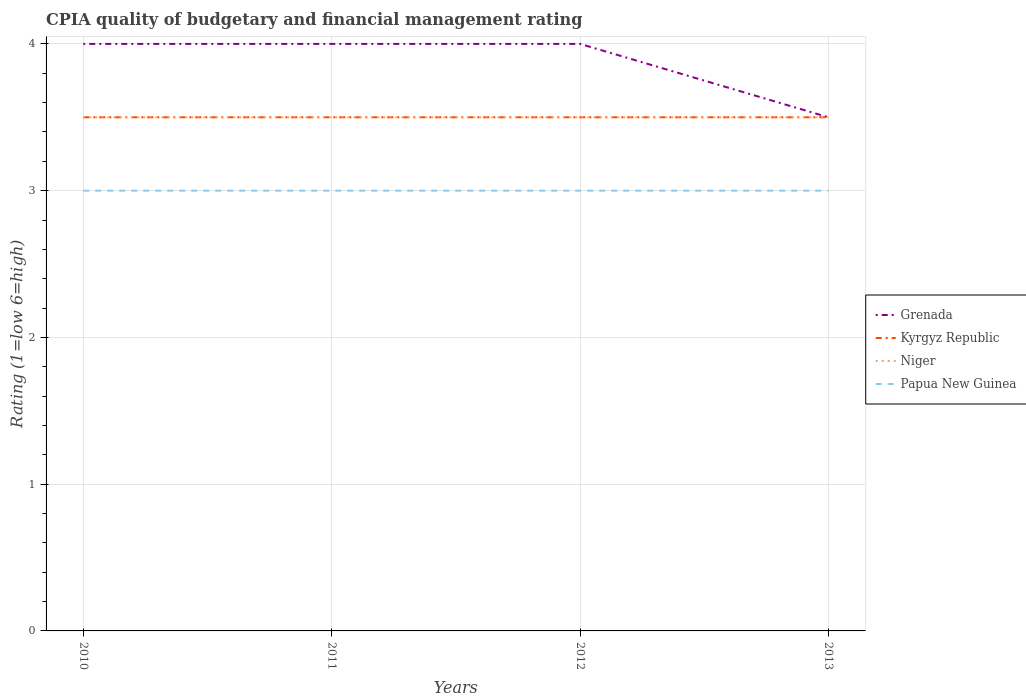How many different coloured lines are there?
Give a very brief answer. 4. Does the line corresponding to Papua New Guinea intersect with the line corresponding to Grenada?
Your answer should be compact. No. Is the number of lines equal to the number of legend labels?
Make the answer very short. Yes. What is the difference between the highest and the second highest CPIA rating in Niger?
Your answer should be compact. 0. What is the difference between the highest and the lowest CPIA rating in Papua New Guinea?
Offer a terse response. 0. Is the CPIA rating in Niger strictly greater than the CPIA rating in Grenada over the years?
Ensure brevity in your answer.  No. What is the difference between two consecutive major ticks on the Y-axis?
Your response must be concise. 1. Are the values on the major ticks of Y-axis written in scientific E-notation?
Your answer should be compact. No. Does the graph contain any zero values?
Your response must be concise. No. Where does the legend appear in the graph?
Provide a succinct answer. Center right. How are the legend labels stacked?
Ensure brevity in your answer.  Vertical. What is the title of the graph?
Offer a very short reply. CPIA quality of budgetary and financial management rating. Does "East Asia (developing only)" appear as one of the legend labels in the graph?
Your response must be concise. No. What is the label or title of the X-axis?
Provide a short and direct response. Years. What is the label or title of the Y-axis?
Provide a succinct answer. Rating (1=low 6=high). What is the Rating (1=low 6=high) in Kyrgyz Republic in 2010?
Offer a very short reply. 3.5. What is the Rating (1=low 6=high) of Niger in 2010?
Your answer should be very brief. 3.5. What is the Rating (1=low 6=high) of Grenada in 2011?
Keep it short and to the point. 4. What is the Rating (1=low 6=high) of Niger in 2011?
Provide a short and direct response. 3.5. What is the Rating (1=low 6=high) of Kyrgyz Republic in 2012?
Your answer should be very brief. 3.5. What is the Rating (1=low 6=high) in Niger in 2012?
Make the answer very short. 3.5. Across all years, what is the maximum Rating (1=low 6=high) in Grenada?
Offer a very short reply. 4. Across all years, what is the maximum Rating (1=low 6=high) of Kyrgyz Republic?
Keep it short and to the point. 3.5. Across all years, what is the maximum Rating (1=low 6=high) of Niger?
Offer a terse response. 3.5. Across all years, what is the minimum Rating (1=low 6=high) in Kyrgyz Republic?
Your response must be concise. 3.5. Across all years, what is the minimum Rating (1=low 6=high) of Niger?
Provide a succinct answer. 3.5. Across all years, what is the minimum Rating (1=low 6=high) of Papua New Guinea?
Make the answer very short. 3. What is the total Rating (1=low 6=high) of Grenada in the graph?
Your answer should be very brief. 15.5. What is the total Rating (1=low 6=high) of Kyrgyz Republic in the graph?
Offer a very short reply. 14. What is the total Rating (1=low 6=high) of Papua New Guinea in the graph?
Offer a very short reply. 12. What is the difference between the Rating (1=low 6=high) of Grenada in 2010 and that in 2011?
Make the answer very short. 0. What is the difference between the Rating (1=low 6=high) of Kyrgyz Republic in 2010 and that in 2011?
Your response must be concise. 0. What is the difference between the Rating (1=low 6=high) of Niger in 2010 and that in 2011?
Keep it short and to the point. 0. What is the difference between the Rating (1=low 6=high) of Papua New Guinea in 2010 and that in 2011?
Your answer should be very brief. 0. What is the difference between the Rating (1=low 6=high) of Niger in 2010 and that in 2012?
Your answer should be compact. 0. What is the difference between the Rating (1=low 6=high) of Papua New Guinea in 2010 and that in 2012?
Provide a short and direct response. 0. What is the difference between the Rating (1=low 6=high) in Kyrgyz Republic in 2010 and that in 2013?
Provide a short and direct response. 0. What is the difference between the Rating (1=low 6=high) in Papua New Guinea in 2011 and that in 2012?
Make the answer very short. 0. What is the difference between the Rating (1=low 6=high) of Grenada in 2011 and that in 2013?
Your answer should be compact. 0.5. What is the difference between the Rating (1=low 6=high) of Papua New Guinea in 2011 and that in 2013?
Keep it short and to the point. 0. What is the difference between the Rating (1=low 6=high) of Kyrgyz Republic in 2012 and that in 2013?
Offer a terse response. 0. What is the difference between the Rating (1=low 6=high) of Niger in 2012 and that in 2013?
Provide a short and direct response. 0. What is the difference between the Rating (1=low 6=high) of Papua New Guinea in 2012 and that in 2013?
Ensure brevity in your answer.  0. What is the difference between the Rating (1=low 6=high) in Grenada in 2010 and the Rating (1=low 6=high) in Niger in 2011?
Make the answer very short. 0.5. What is the difference between the Rating (1=low 6=high) in Grenada in 2010 and the Rating (1=low 6=high) in Papua New Guinea in 2011?
Ensure brevity in your answer.  1. What is the difference between the Rating (1=low 6=high) in Kyrgyz Republic in 2010 and the Rating (1=low 6=high) in Papua New Guinea in 2011?
Provide a short and direct response. 0.5. What is the difference between the Rating (1=low 6=high) of Niger in 2010 and the Rating (1=low 6=high) of Papua New Guinea in 2011?
Offer a very short reply. 0.5. What is the difference between the Rating (1=low 6=high) in Grenada in 2010 and the Rating (1=low 6=high) in Kyrgyz Republic in 2012?
Provide a succinct answer. 0.5. What is the difference between the Rating (1=low 6=high) of Grenada in 2010 and the Rating (1=low 6=high) of Papua New Guinea in 2012?
Provide a short and direct response. 1. What is the difference between the Rating (1=low 6=high) in Kyrgyz Republic in 2010 and the Rating (1=low 6=high) in Niger in 2012?
Ensure brevity in your answer.  0. What is the difference between the Rating (1=low 6=high) in Grenada in 2010 and the Rating (1=low 6=high) in Kyrgyz Republic in 2013?
Ensure brevity in your answer.  0.5. What is the difference between the Rating (1=low 6=high) in Grenada in 2010 and the Rating (1=low 6=high) in Papua New Guinea in 2013?
Your answer should be very brief. 1. What is the difference between the Rating (1=low 6=high) of Niger in 2010 and the Rating (1=low 6=high) of Papua New Guinea in 2013?
Offer a terse response. 0.5. What is the difference between the Rating (1=low 6=high) in Grenada in 2011 and the Rating (1=low 6=high) in Niger in 2012?
Your response must be concise. 0.5. What is the difference between the Rating (1=low 6=high) of Grenada in 2011 and the Rating (1=low 6=high) of Papua New Guinea in 2012?
Ensure brevity in your answer.  1. What is the difference between the Rating (1=low 6=high) in Kyrgyz Republic in 2011 and the Rating (1=low 6=high) in Niger in 2012?
Provide a short and direct response. 0. What is the difference between the Rating (1=low 6=high) in Kyrgyz Republic in 2011 and the Rating (1=low 6=high) in Papua New Guinea in 2012?
Provide a short and direct response. 0.5. What is the difference between the Rating (1=low 6=high) of Grenada in 2011 and the Rating (1=low 6=high) of Papua New Guinea in 2013?
Your answer should be very brief. 1. What is the difference between the Rating (1=low 6=high) of Kyrgyz Republic in 2011 and the Rating (1=low 6=high) of Niger in 2013?
Your response must be concise. 0. What is the difference between the Rating (1=low 6=high) of Niger in 2011 and the Rating (1=low 6=high) of Papua New Guinea in 2013?
Your answer should be very brief. 0.5. What is the difference between the Rating (1=low 6=high) in Kyrgyz Republic in 2012 and the Rating (1=low 6=high) in Niger in 2013?
Provide a succinct answer. 0. What is the difference between the Rating (1=low 6=high) of Kyrgyz Republic in 2012 and the Rating (1=low 6=high) of Papua New Guinea in 2013?
Give a very brief answer. 0.5. What is the average Rating (1=low 6=high) in Grenada per year?
Provide a succinct answer. 3.88. What is the average Rating (1=low 6=high) of Niger per year?
Keep it short and to the point. 3.5. In the year 2010, what is the difference between the Rating (1=low 6=high) in Grenada and Rating (1=low 6=high) in Niger?
Make the answer very short. 0.5. In the year 2010, what is the difference between the Rating (1=low 6=high) in Kyrgyz Republic and Rating (1=low 6=high) in Niger?
Provide a short and direct response. 0. In the year 2010, what is the difference between the Rating (1=low 6=high) in Niger and Rating (1=low 6=high) in Papua New Guinea?
Keep it short and to the point. 0.5. In the year 2011, what is the difference between the Rating (1=low 6=high) in Grenada and Rating (1=low 6=high) in Kyrgyz Republic?
Make the answer very short. 0.5. In the year 2011, what is the difference between the Rating (1=low 6=high) in Grenada and Rating (1=low 6=high) in Niger?
Provide a short and direct response. 0.5. In the year 2011, what is the difference between the Rating (1=low 6=high) of Grenada and Rating (1=low 6=high) of Papua New Guinea?
Your response must be concise. 1. In the year 2011, what is the difference between the Rating (1=low 6=high) in Kyrgyz Republic and Rating (1=low 6=high) in Niger?
Your answer should be very brief. 0. In the year 2012, what is the difference between the Rating (1=low 6=high) in Grenada and Rating (1=low 6=high) in Kyrgyz Republic?
Provide a succinct answer. 0.5. In the year 2012, what is the difference between the Rating (1=low 6=high) of Grenada and Rating (1=low 6=high) of Niger?
Offer a very short reply. 0.5. In the year 2012, what is the difference between the Rating (1=low 6=high) in Grenada and Rating (1=low 6=high) in Papua New Guinea?
Provide a succinct answer. 1. In the year 2012, what is the difference between the Rating (1=low 6=high) in Kyrgyz Republic and Rating (1=low 6=high) in Niger?
Make the answer very short. 0. In the year 2012, what is the difference between the Rating (1=low 6=high) in Niger and Rating (1=low 6=high) in Papua New Guinea?
Make the answer very short. 0.5. In the year 2013, what is the difference between the Rating (1=low 6=high) of Kyrgyz Republic and Rating (1=low 6=high) of Niger?
Make the answer very short. 0. What is the ratio of the Rating (1=low 6=high) of Grenada in 2010 to that in 2011?
Offer a very short reply. 1. What is the ratio of the Rating (1=low 6=high) of Niger in 2010 to that in 2011?
Your answer should be compact. 1. What is the ratio of the Rating (1=low 6=high) of Niger in 2010 to that in 2012?
Your answer should be very brief. 1. What is the ratio of the Rating (1=low 6=high) of Kyrgyz Republic in 2010 to that in 2013?
Your answer should be very brief. 1. What is the ratio of the Rating (1=low 6=high) in Niger in 2010 to that in 2013?
Provide a short and direct response. 1. What is the ratio of the Rating (1=low 6=high) of Grenada in 2011 to that in 2012?
Ensure brevity in your answer.  1. What is the ratio of the Rating (1=low 6=high) of Niger in 2011 to that in 2012?
Your answer should be compact. 1. What is the ratio of the Rating (1=low 6=high) of Niger in 2011 to that in 2013?
Offer a terse response. 1. What is the ratio of the Rating (1=low 6=high) of Kyrgyz Republic in 2012 to that in 2013?
Make the answer very short. 1. What is the ratio of the Rating (1=low 6=high) of Papua New Guinea in 2012 to that in 2013?
Offer a very short reply. 1. What is the difference between the highest and the second highest Rating (1=low 6=high) in Grenada?
Your answer should be compact. 0. What is the difference between the highest and the second highest Rating (1=low 6=high) in Kyrgyz Republic?
Ensure brevity in your answer.  0. What is the difference between the highest and the lowest Rating (1=low 6=high) in Kyrgyz Republic?
Give a very brief answer. 0. What is the difference between the highest and the lowest Rating (1=low 6=high) in Niger?
Offer a very short reply. 0. 